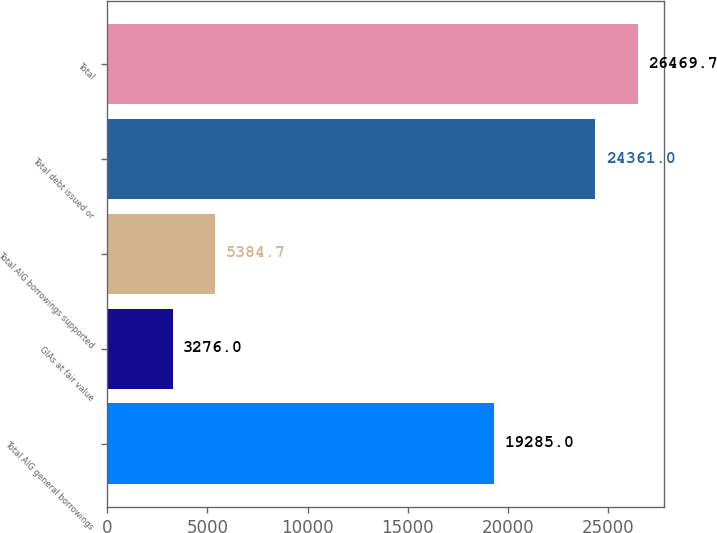<chart> <loc_0><loc_0><loc_500><loc_500><bar_chart><fcel>Total AIG general borrowings<fcel>GIAs at fair value<fcel>Total AIG borrowings supported<fcel>Total debt issued or<fcel>Total<nl><fcel>19285<fcel>3276<fcel>5384.7<fcel>24361<fcel>26469.7<nl></chart> 